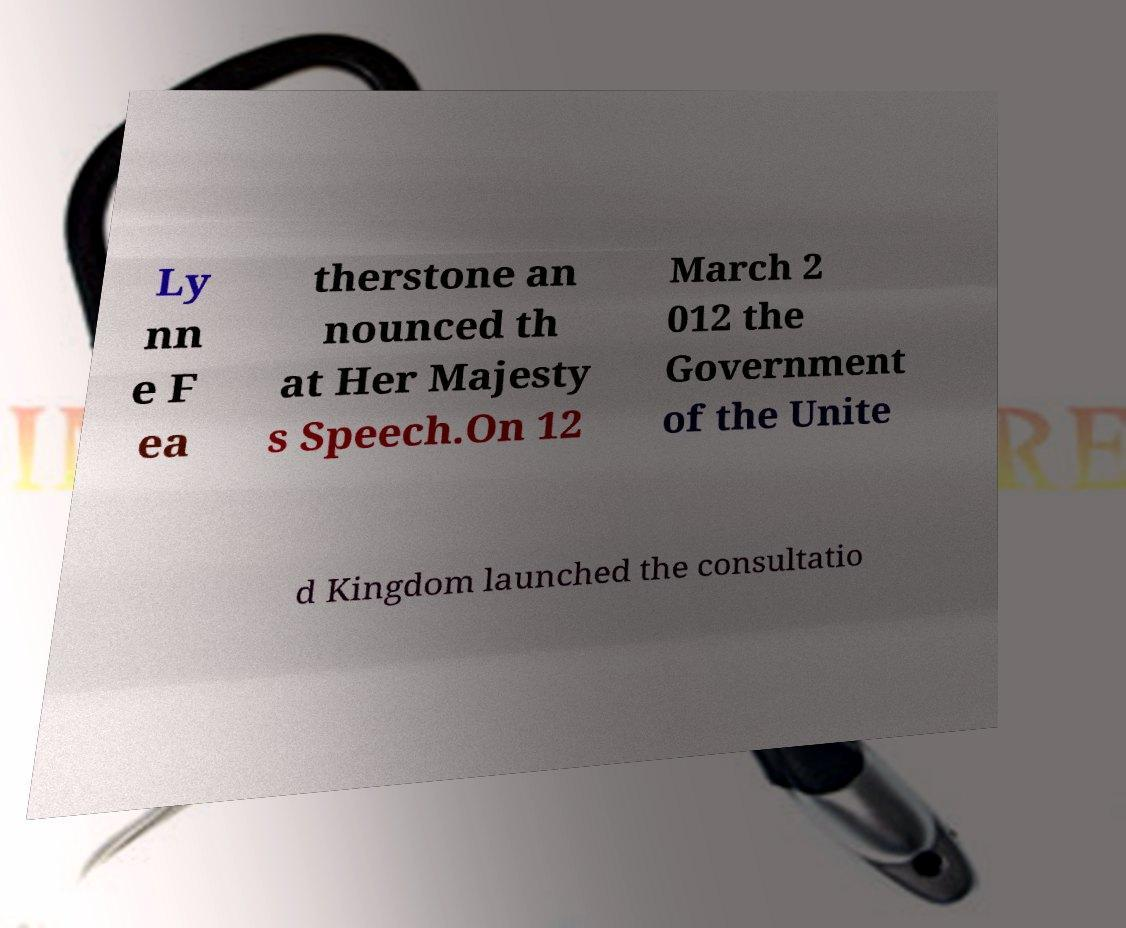Please read and relay the text visible in this image. What does it say? Ly nn e F ea therstone an nounced th at Her Majesty s Speech.On 12 March 2 012 the Government of the Unite d Kingdom launched the consultatio 